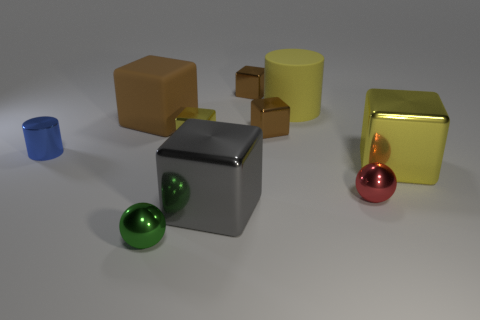How many brown blocks must be subtracted to get 1 brown blocks? 2 Subtract all shiny cubes. How many cubes are left? 1 Subtract all red balls. How many balls are left? 1 Subtract 1 cubes. How many cubes are left? 5 Add 8 yellow matte cylinders. How many yellow matte cylinders exist? 9 Subtract 1 red balls. How many objects are left? 9 Subtract all spheres. How many objects are left? 8 Subtract all brown blocks. Subtract all blue cylinders. How many blocks are left? 3 Subtract all green cylinders. How many blue cubes are left? 0 Subtract all brown cubes. Subtract all small blue shiny objects. How many objects are left? 6 